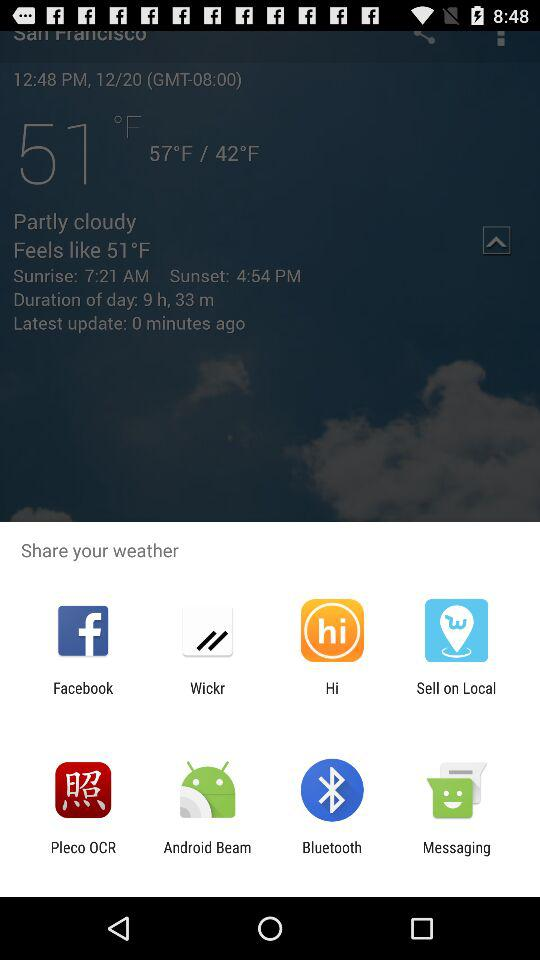How many degrees is the difference between the high and low temperatures?
Answer the question using a single word or phrase. 15°F 